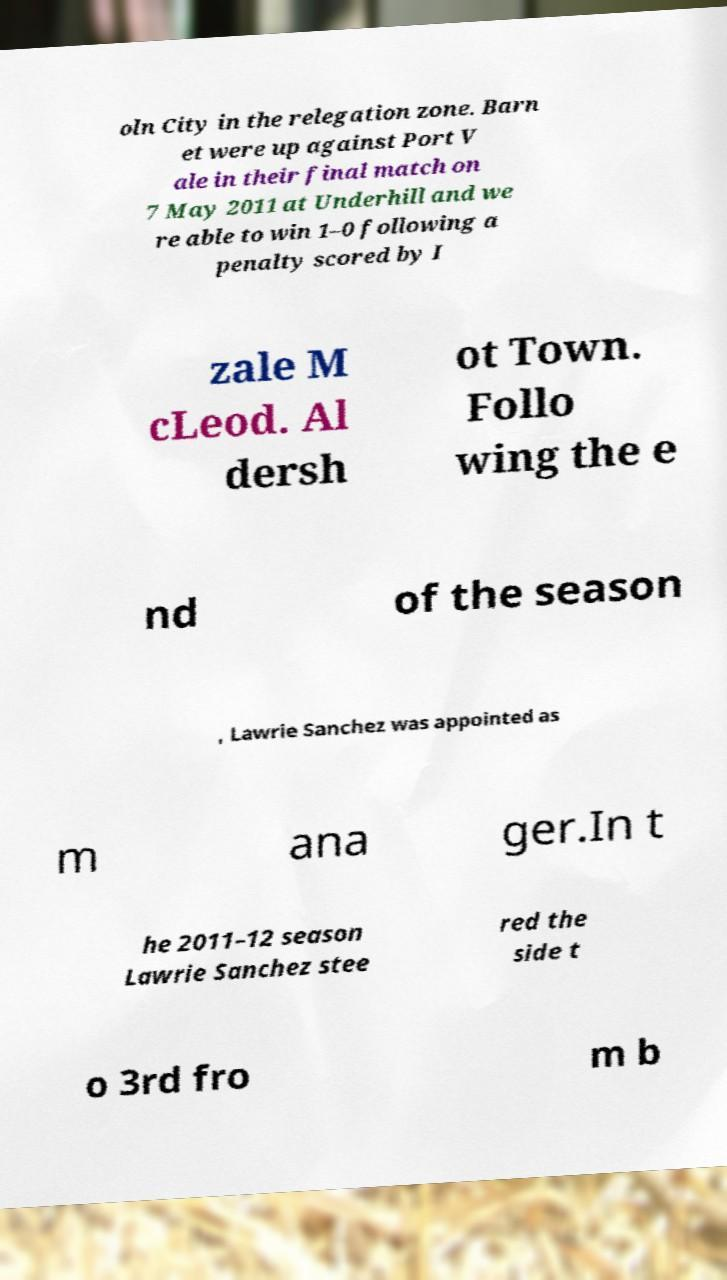What messages or text are displayed in this image? I need them in a readable, typed format. oln City in the relegation zone. Barn et were up against Port V ale in their final match on 7 May 2011 at Underhill and we re able to win 1–0 following a penalty scored by I zale M cLeod. Al dersh ot Town. Follo wing the e nd of the season , Lawrie Sanchez was appointed as m ana ger.In t he 2011–12 season Lawrie Sanchez stee red the side t o 3rd fro m b 